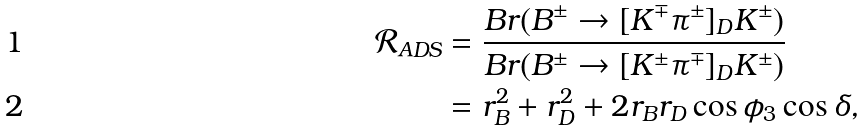Convert formula to latex. <formula><loc_0><loc_0><loc_500><loc_500>\mathcal { R } _ { A D S } & = \frac { B r ( B ^ { \pm } \to [ K ^ { \mp } \pi ^ { \pm } ] _ { D } K ^ { \pm } ) } { B r ( B ^ { \pm } \to [ K ^ { \pm } \pi ^ { \mp } ] _ { D } K ^ { \pm } ) } \\ & = r _ { B } ^ { 2 } + r _ { D } ^ { 2 } + 2 r _ { B } r _ { D } \cos \phi _ { 3 } \cos \delta ,</formula> 